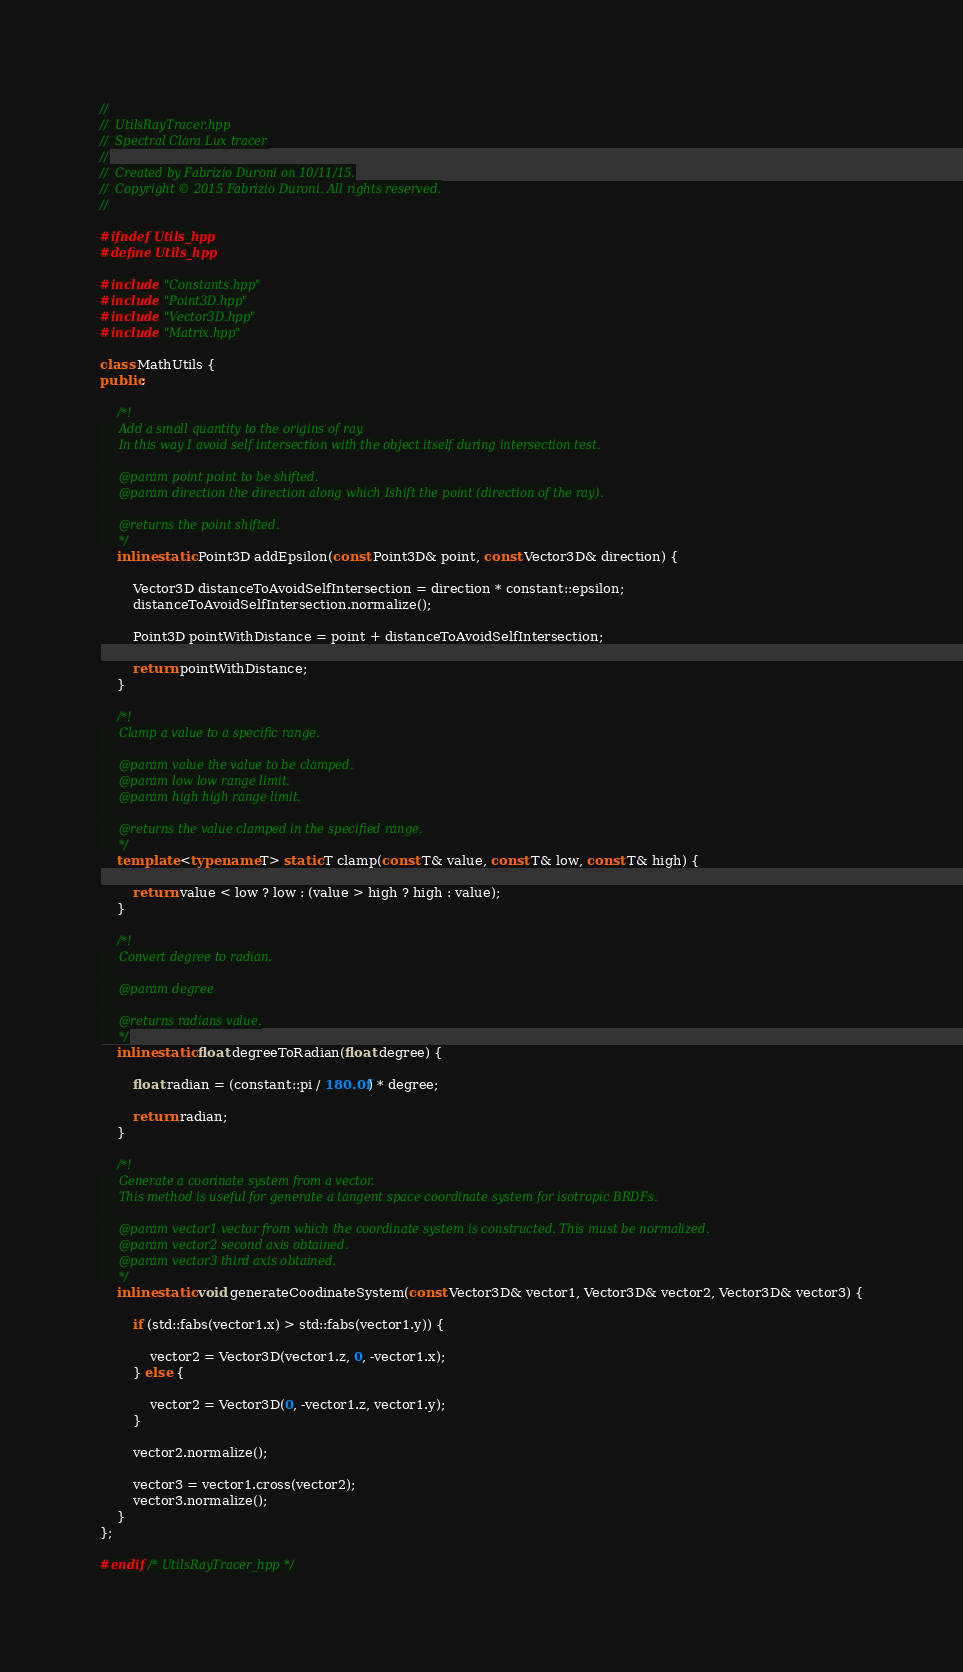<code> <loc_0><loc_0><loc_500><loc_500><_C++_>//
//  UtilsRayTracer.hpp
//  Spectral Clara Lux tracer
//
//  Created by Fabrizio Duroni on 10/11/15.
//  Copyright © 2015 Fabrizio Duroni. All rights reserved.
//

#ifndef Utils_hpp
#define Utils_hpp

#include "Constants.hpp"
#include "Point3D.hpp"
#include "Vector3D.hpp"
#include "Matrix.hpp"

class MathUtils {
public:
    
    /*!
     Add a small quantity to the origins of ray.
     In this way I avoid self intersection with the object itself during intersection test.
     
     @param point point to be shifted.
     @param direction the direction along which Ishift the point (direction of the ray).
     
     @returns the point shifted.
     */
    inline static Point3D addEpsilon(const Point3D& point, const Vector3D& direction) {
        
        Vector3D distanceToAvoidSelfIntersection = direction * constant::epsilon;
        distanceToAvoidSelfIntersection.normalize();
        
        Point3D pointWithDistance = point + distanceToAvoidSelfIntersection;
        
        return pointWithDistance;
    }
    
    /*!
     Clamp a value to a specific range.
     
     @param value the value to be clamped.
     @param low low range limit.
     @param high high range limit.
     
     @returns the value clamped in the specified range.
     */
    template <typename T> static T clamp(const T& value, const T& low, const T& high) {
        
        return value < low ? low : (value > high ? high : value);
    }
    
    /*!
     Convert degree to radian.
     
     @param degree
     
     @returns radians value.
     */
    inline static float degreeToRadian(float degree) {
        
        float radian = (constant::pi / 180.0f) * degree;
        
        return radian;
    }
    
    /*!
     Generate a coorinate system from a vector.
     This method is useful for generate a tangent space coordinate system for isotropic BRDFs.
     
     @param vector1 vector from which the coordinate system is constructed. This must be normalized.
     @param vector2 second axis obtained.
     @param vector3 third axis obtained.
     */
    inline static void generateCoodinateSystem(const Vector3D& vector1, Vector3D& vector2, Vector3D& vector3) {

        if (std::fabs(vector1.x) > std::fabs(vector1.y)) {
            
            vector2 = Vector3D(vector1.z, 0, -vector1.x);
        } else {
            
            vector2 = Vector3D(0, -vector1.z, vector1.y);
        }
        
        vector2.normalize();
        
        vector3 = vector1.cross(vector2);
        vector3.normalize();
    }
};

#endif /* UtilsRayTracer_hpp */
</code> 